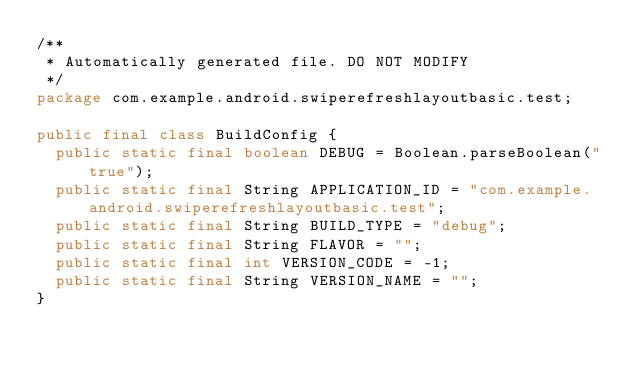Convert code to text. <code><loc_0><loc_0><loc_500><loc_500><_Java_>/**
 * Automatically generated file. DO NOT MODIFY
 */
package com.example.android.swiperefreshlayoutbasic.test;

public final class BuildConfig {
  public static final boolean DEBUG = Boolean.parseBoolean("true");
  public static final String APPLICATION_ID = "com.example.android.swiperefreshlayoutbasic.test";
  public static final String BUILD_TYPE = "debug";
  public static final String FLAVOR = "";
  public static final int VERSION_CODE = -1;
  public static final String VERSION_NAME = "";
}
</code> 